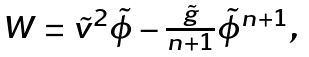<formula> <loc_0><loc_0><loc_500><loc_500>\begin{array} { r r } W = { \tilde { v } } ^ { 2 } { \tilde { \phi } } - \frac { \tilde { g } } { n + 1 } { \tilde { \phi } } ^ { n + 1 } , & \end{array}</formula> 